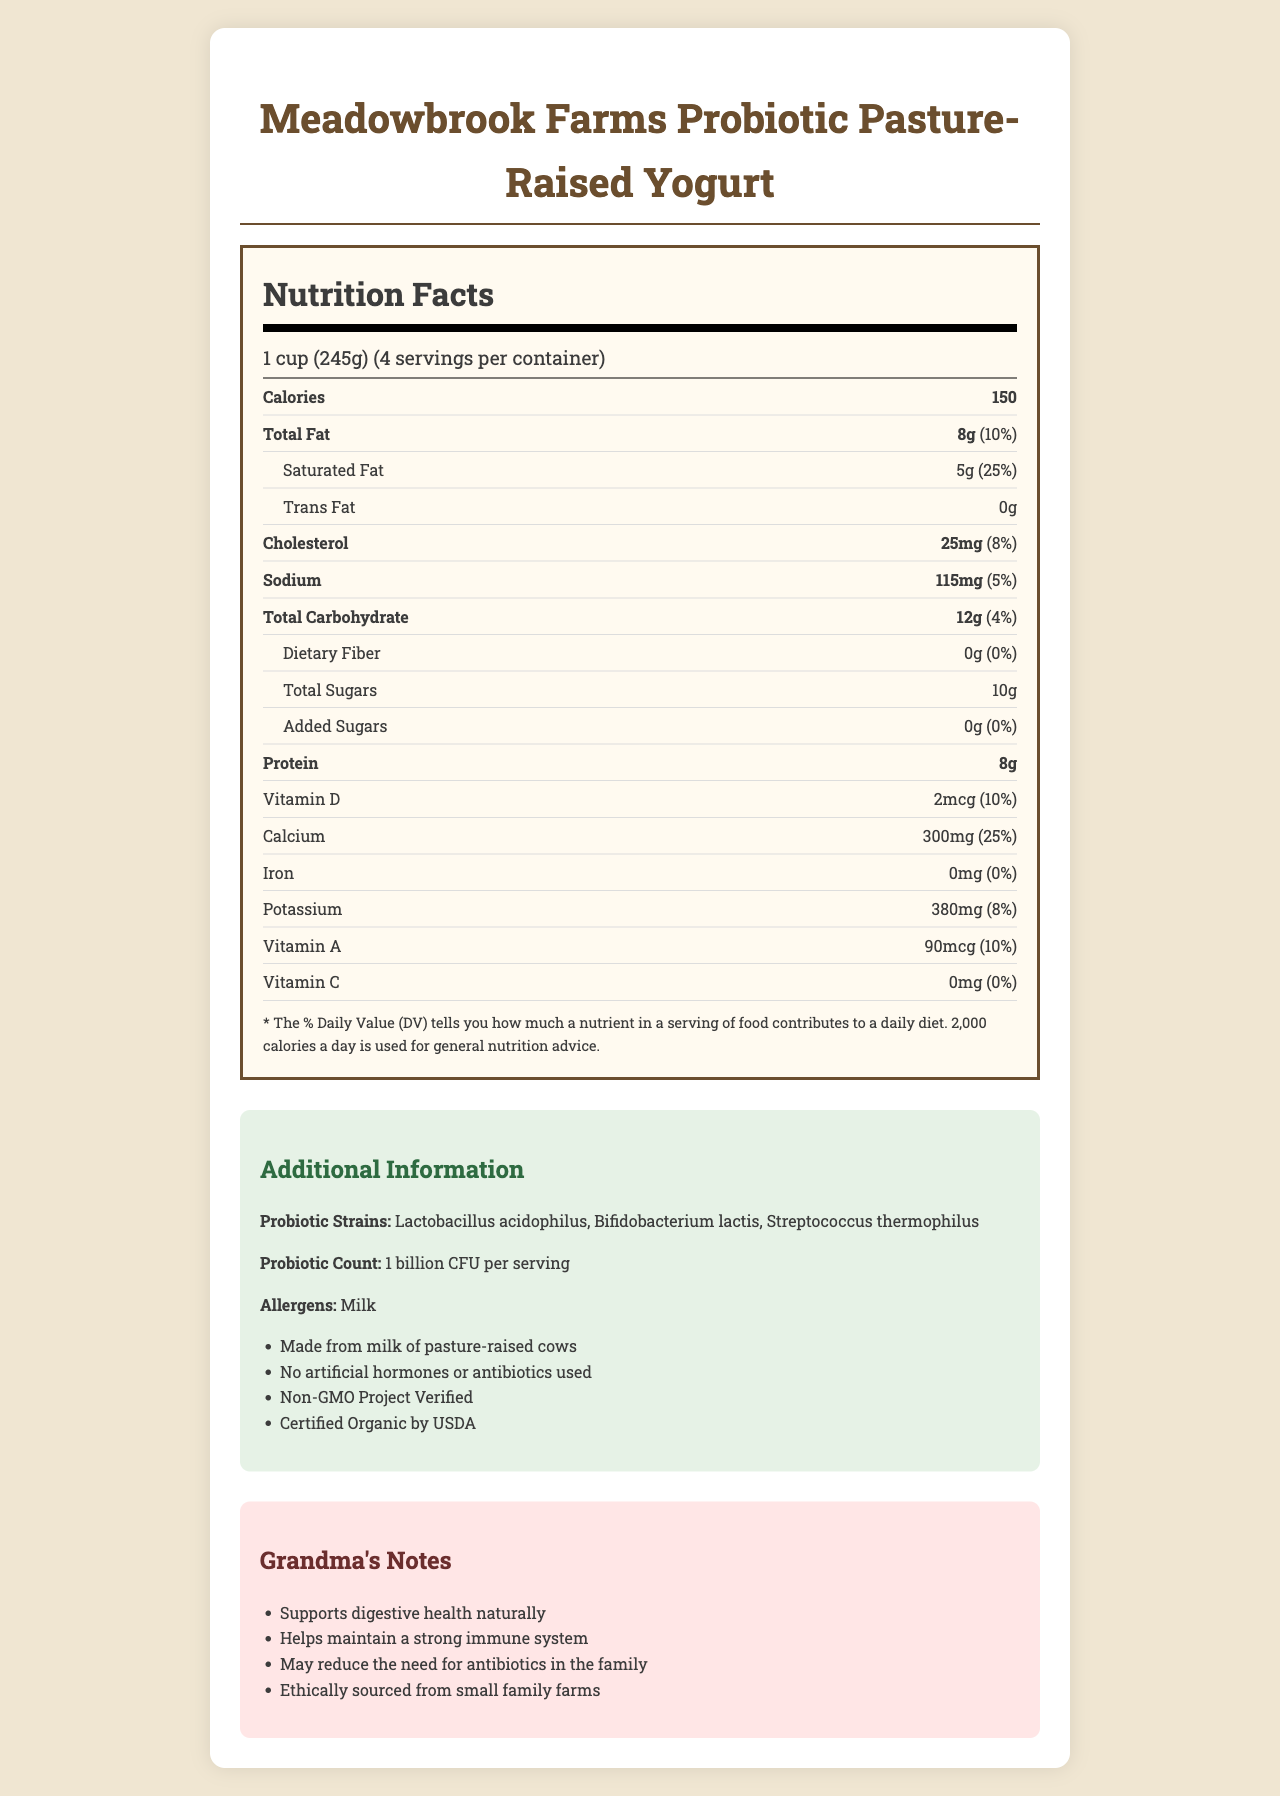what is the serving size? The serving size is listed at the beginning of the Nutrition Facts section.
Answer: 1 cup (245g) how many calories are in one serving? The calories per serving are mentioned directly under the serving size information.
Answer: 150 how much protein is in one serving of the yogurt? The protein content is listed in the Nutrition Facts under the section labeled "Protein."
Answer: 8g what is the daily value percentage of calcium in this yogurt? The daily value percentage for calcium is provided in the Nutrition Facts section as 25%.
Answer: 25% which vitamins have their daily values listed? These vitamins have their daily values provided in the Nutrition Facts section.
Answer: Vitamin D, Calcium, Potassium, Vitamin A what is the total fat content in one serving of the yogurt? A. 5g B. 8g C. 10g D. 25g The total fat content is listed as 8g in the Nutrition Facts section.
Answer: B what is the amount of added sugar per serving? 1. 0g 2. 2g 3. 5g 4. 10g The amount of added sugar is clearly listed as 0g in the Nutrition Facts section.
Answer: 1 what kind of cows is the milk sourced from? A. Industrially raised cows B. Organic cows C. Pasture-raised cows D. Grass-fed cows The additional information section states that the milk is from pasture-raised cows.
Answer: C does this yogurt contain any artificial hormones or antibiotics? The additional information section specifies that no artificial hormones or antibiotics are used.
Answer: No is the product certified organic by USDA? The additional information section includes that the product is Certified Organic by USDA.
Answer: Yes does this yogurt support digestive health naturally? The grandmotherly notes emphasize that the yogurt supports digestive health naturally.
Answer: Yes how many servings are in one container of this yogurt? The servings per container are listed near the beginning under the serving size information in the Nutrition Facts section.
Answer: 4 how much potassium is in a serving of this yogurt? The amount of potassium is listed in the Nutrition Facts section.
Answer: 380mg what allergens are present in this yogurt? The allergens are listed in the additional information section.
Answer: Milk how many grams of total carbohydrates are in each serving of this yogurt? The total carbohydrate content is listed in the Nutrition Facts section.
Answer: 12g what are the primary benefits noted for the yogurt in the document? The grandmotherly notes section lists these primary benefits.
Answer: Supports digestive health, helps maintain a strong immune system, may reduce need for antibiotics, ethically sourced can you list all the probiotic strains in this yogurt? The probiotic strains are listed under the additional information section.
Answer: Lactobacillus acidophilus, Bifidobacterium lactis, Streptococcus thermophilus is it mentioned how the cows are raised in any specific health or environmental condition? The additional information clearly states "Made from milk of pasture-raised cows."
Answer: Yes, pasture-raised how much cholesterol does one serving of yogurt contain? The cholesterol content is listed in the Nutrition Facts section.
Answer: 25mg what percentage of daily saturated fat is provided by each serving of the yogurt? The daily value percentage of saturated fat is mentioned in the Nutrition Facts section.
Answer: 25% describe the main idea of the document. The document comprehensively describes the yogurt's nutritional content, probiotic strains, and additional information such as certifications, allergens, and health benefits to help consumers make informed choices.
Answer: The main idea of the document is to provide the Nutrition Facts of Meadowbrook Farms Probiotic Pasture-Raised Yogurt, detailing its nutritional content, probiotic strains, allergens, and additional information about its production, along with highlighting health benefits and ethical sourcing. is the yogurt non-GMO verified? The additional information section mentions that the yogurt is Non-GMO Project Verified.
Answer: Yes what is the price of this yogurt? The document does not provide any details regarding the price of the yogurt.
Answer: Not enough information 